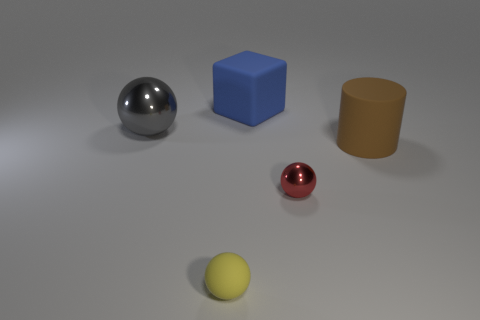Add 2 matte things. How many objects exist? 7 Subtract all balls. How many objects are left? 2 Add 4 brown matte objects. How many brown matte objects exist? 5 Subtract 0 green cylinders. How many objects are left? 5 Subtract all blue objects. Subtract all metallic spheres. How many objects are left? 2 Add 4 brown matte cylinders. How many brown matte cylinders are left? 5 